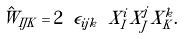<formula> <loc_0><loc_0><loc_500><loc_500>\hat { W } _ { I J K } = 2 \ \epsilon _ { i j k } \ X _ { I } ^ { i } X _ { J } ^ { j } X _ { K } ^ { k } .</formula> 